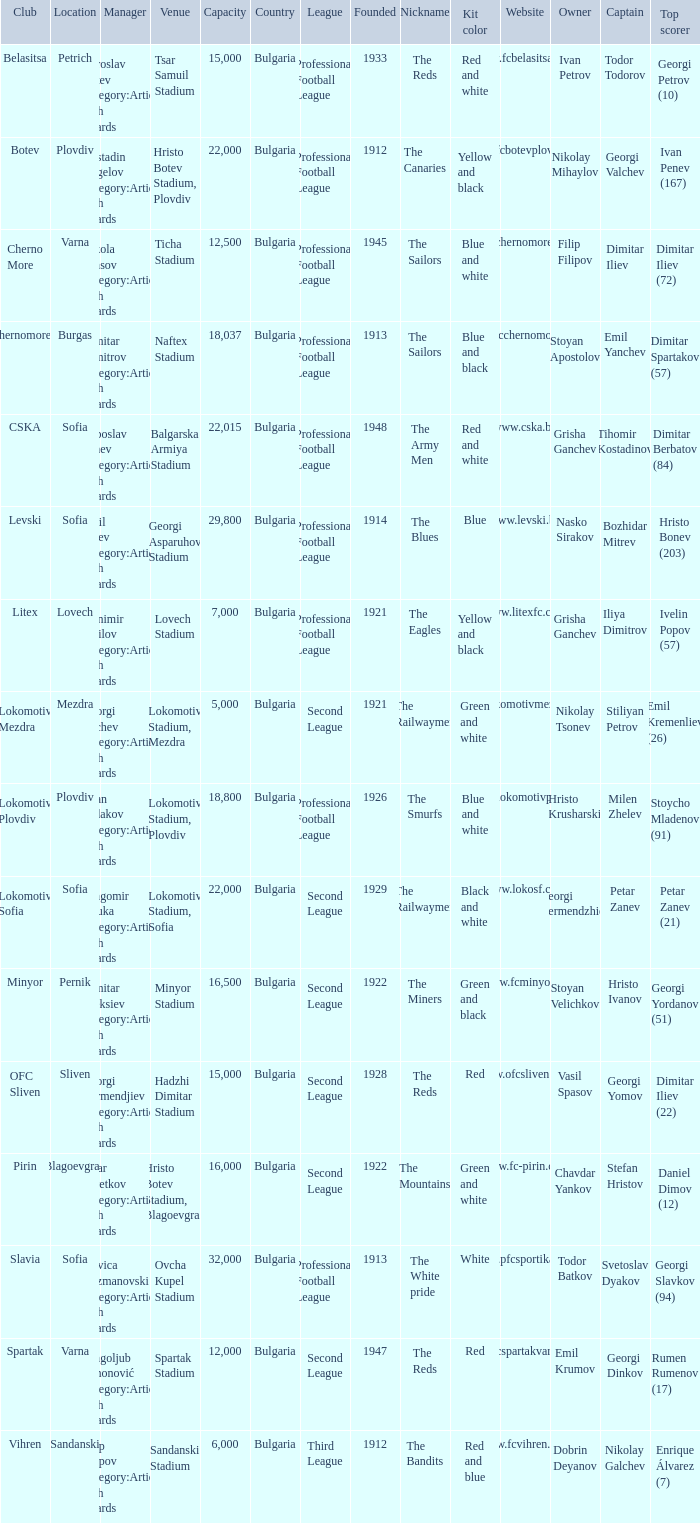What is the highest capacity for the venue, ticha stadium, located in varna? 12500.0. 